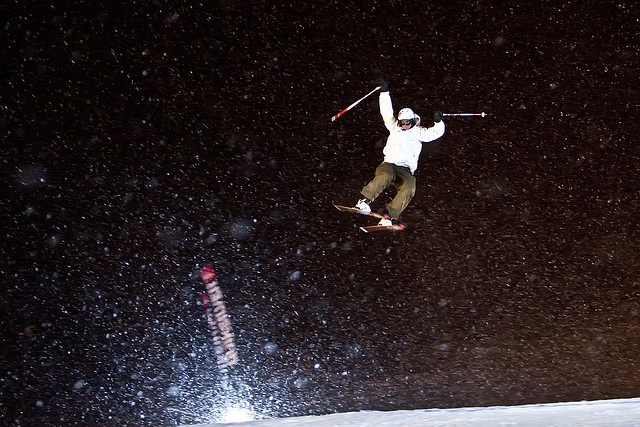Describe the objects in this image and their specific colors. I can see people in black, white, and gray tones and skis in black, maroon, brown, and gray tones in this image. 